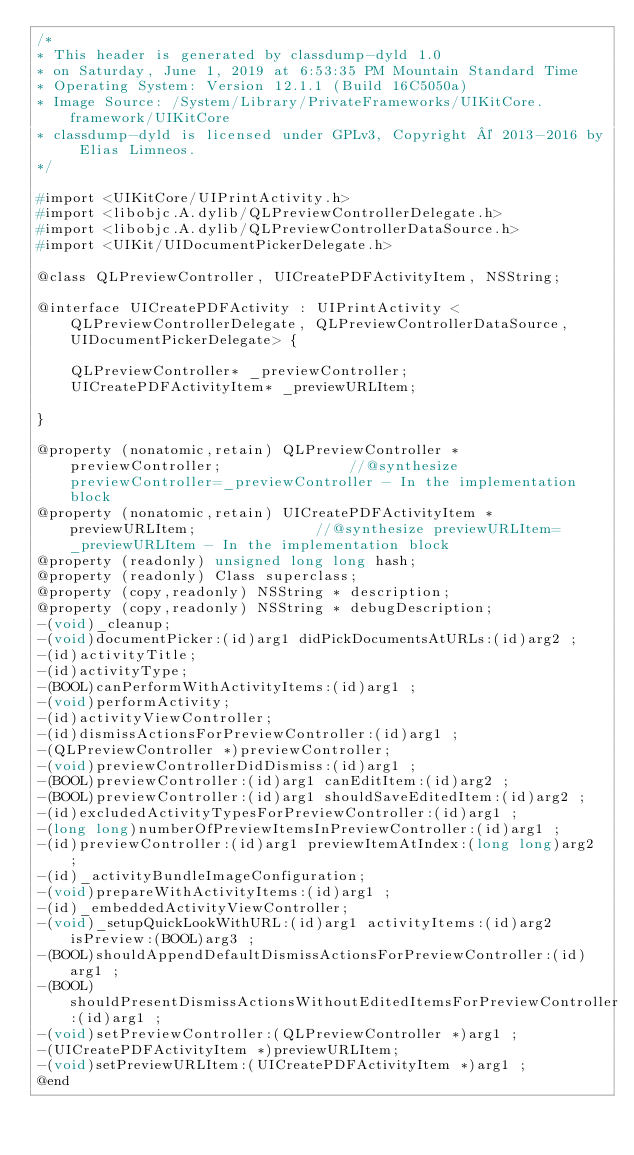<code> <loc_0><loc_0><loc_500><loc_500><_C_>/*
* This header is generated by classdump-dyld 1.0
* on Saturday, June 1, 2019 at 6:53:35 PM Mountain Standard Time
* Operating System: Version 12.1.1 (Build 16C5050a)
* Image Source: /System/Library/PrivateFrameworks/UIKitCore.framework/UIKitCore
* classdump-dyld is licensed under GPLv3, Copyright © 2013-2016 by Elias Limneos.
*/

#import <UIKitCore/UIPrintActivity.h>
#import <libobjc.A.dylib/QLPreviewControllerDelegate.h>
#import <libobjc.A.dylib/QLPreviewControllerDataSource.h>
#import <UIKit/UIDocumentPickerDelegate.h>

@class QLPreviewController, UICreatePDFActivityItem, NSString;

@interface UICreatePDFActivity : UIPrintActivity <QLPreviewControllerDelegate, QLPreviewControllerDataSource, UIDocumentPickerDelegate> {

	QLPreviewController* _previewController;
	UICreatePDFActivityItem* _previewURLItem;

}

@property (nonatomic,retain) QLPreviewController * previewController;               //@synthesize previewController=_previewController - In the implementation block
@property (nonatomic,retain) UICreatePDFActivityItem * previewURLItem;              //@synthesize previewURLItem=_previewURLItem - In the implementation block
@property (readonly) unsigned long long hash; 
@property (readonly) Class superclass; 
@property (copy,readonly) NSString * description; 
@property (copy,readonly) NSString * debugDescription; 
-(void)_cleanup;
-(void)documentPicker:(id)arg1 didPickDocumentsAtURLs:(id)arg2 ;
-(id)activityTitle;
-(id)activityType;
-(BOOL)canPerformWithActivityItems:(id)arg1 ;
-(void)performActivity;
-(id)activityViewController;
-(id)dismissActionsForPreviewController:(id)arg1 ;
-(QLPreviewController *)previewController;
-(void)previewControllerDidDismiss:(id)arg1 ;
-(BOOL)previewController:(id)arg1 canEditItem:(id)arg2 ;
-(BOOL)previewController:(id)arg1 shouldSaveEditedItem:(id)arg2 ;
-(id)excludedActivityTypesForPreviewController:(id)arg1 ;
-(long long)numberOfPreviewItemsInPreviewController:(id)arg1 ;
-(id)previewController:(id)arg1 previewItemAtIndex:(long long)arg2 ;
-(id)_activityBundleImageConfiguration;
-(void)prepareWithActivityItems:(id)arg1 ;
-(id)_embeddedActivityViewController;
-(void)_setupQuickLookWithURL:(id)arg1 activityItems:(id)arg2 isPreview:(BOOL)arg3 ;
-(BOOL)shouldAppendDefaultDismissActionsForPreviewController:(id)arg1 ;
-(BOOL)shouldPresentDismissActionsWithoutEditedItemsForPreviewController:(id)arg1 ;
-(void)setPreviewController:(QLPreviewController *)arg1 ;
-(UICreatePDFActivityItem *)previewURLItem;
-(void)setPreviewURLItem:(UICreatePDFActivityItem *)arg1 ;
@end

</code> 